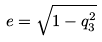<formula> <loc_0><loc_0><loc_500><loc_500>e = \sqrt { 1 - q _ { 3 } ^ { 2 } }</formula> 